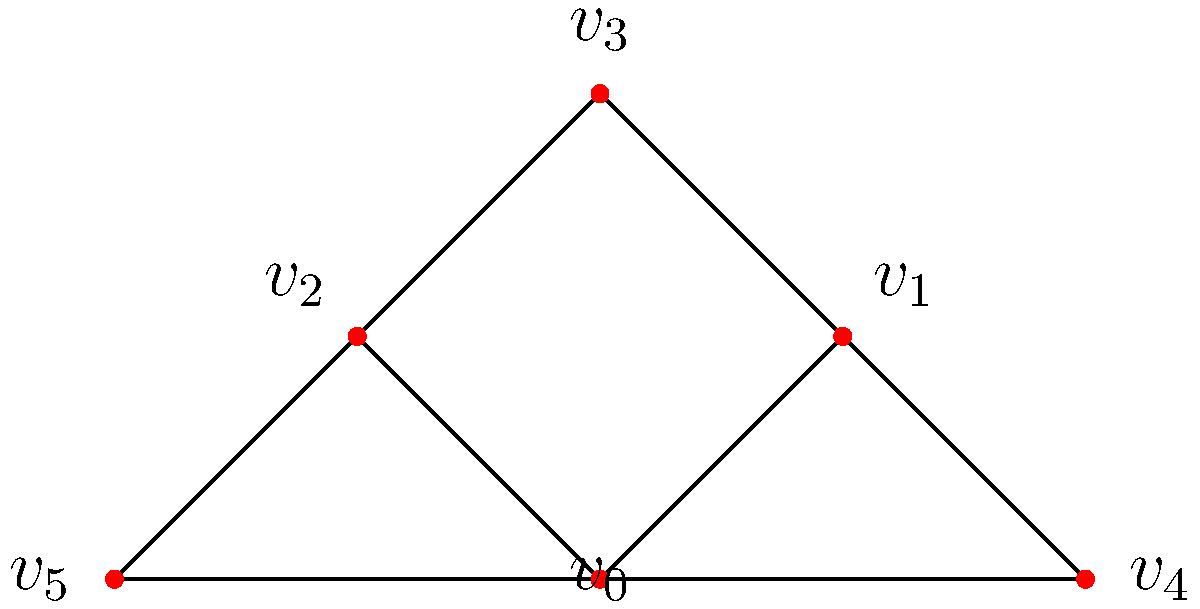In a social network analysis of a film's characters, the graph above represents character interactions. Each vertex represents a character, and edges represent significant interactions. What is the degree centrality of vertex $v_0$, and how might this inform the character's role in the story? To solve this problem, we'll follow these steps:

1. Understand degree centrality:
   Degree centrality is the number of edges connected to a vertex.

2. Count the edges connected to $v_0$:
   - $v_0$ is connected to $v_1$
   - $v_0$ is connected to $v_2$
   - $v_0$ is connected to $v_4$
   - $v_0$ is connected to $v_5$

3. Calculate the degree centrality:
   The degree centrality of $v_0$ is 4.

4. Interpret the result:
   A high degree centrality (4 in this case) suggests that the character represented by $v_0$ is central to the story. They interact with many other characters, potentially indicating:
   - A protagonist or major character
   - A character who connects different subplots or groups
   - A character with significant influence on the story's events

5. Compare to other vertices:
   $v_0$ has the highest degree centrality in the graph, further emphasizing its importance.

This analysis can inform the filmmaker about the character's role, helping to structure the narrative or guide the audience's attention throughout the film.
Answer: 4; central character with multiple connections 